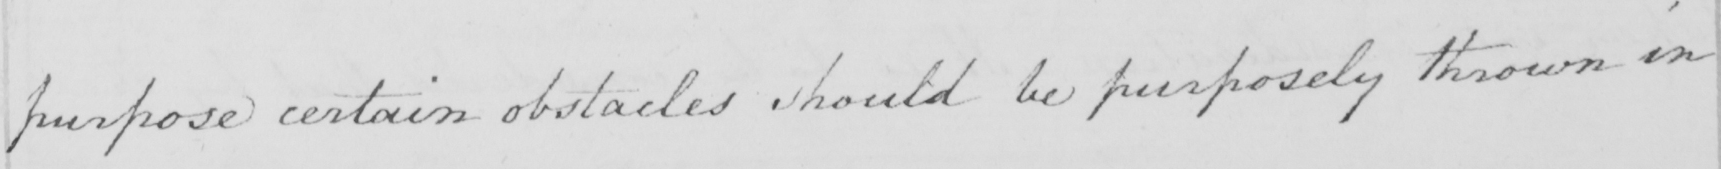What is written in this line of handwriting? purpose certain obstacles should be purposely thrown in 